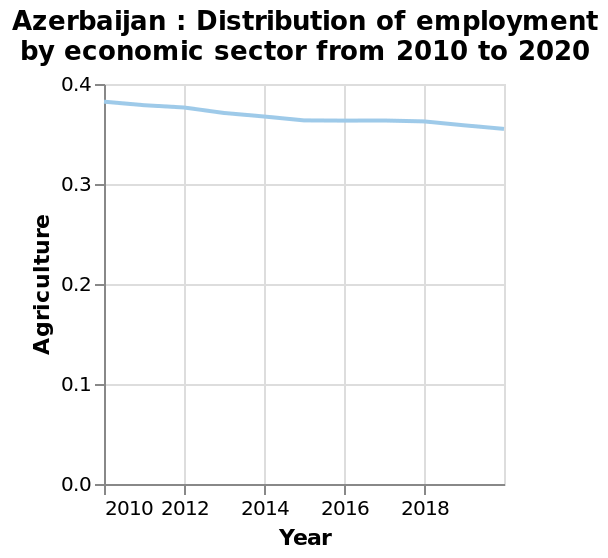<image>
Did Azerbaijan witness an increase or decrease in agriculture employment between 2010 and 2018? Azerbaijan witnessed a decrease in agriculture employment between 2010 and 2018. What was the trend in agriculture employment in Azerbaijan between 2010 and 2018? There has been a slight decline in agriculture employment in Azerbaijan between 2010 and 2018. 